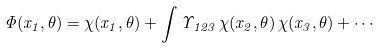<formula> <loc_0><loc_0><loc_500><loc_500>\Phi ( { x } _ { 1 } , \theta ) = \chi ( { x } _ { 1 } , \theta ) + \int \Upsilon _ { 1 2 3 } \, \chi ( { x } _ { 2 } , \theta ) \, \chi ( { x } _ { 3 } , \theta ) + \cdots</formula> 